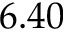<formula> <loc_0><loc_0><loc_500><loc_500>6 . 4 0</formula> 